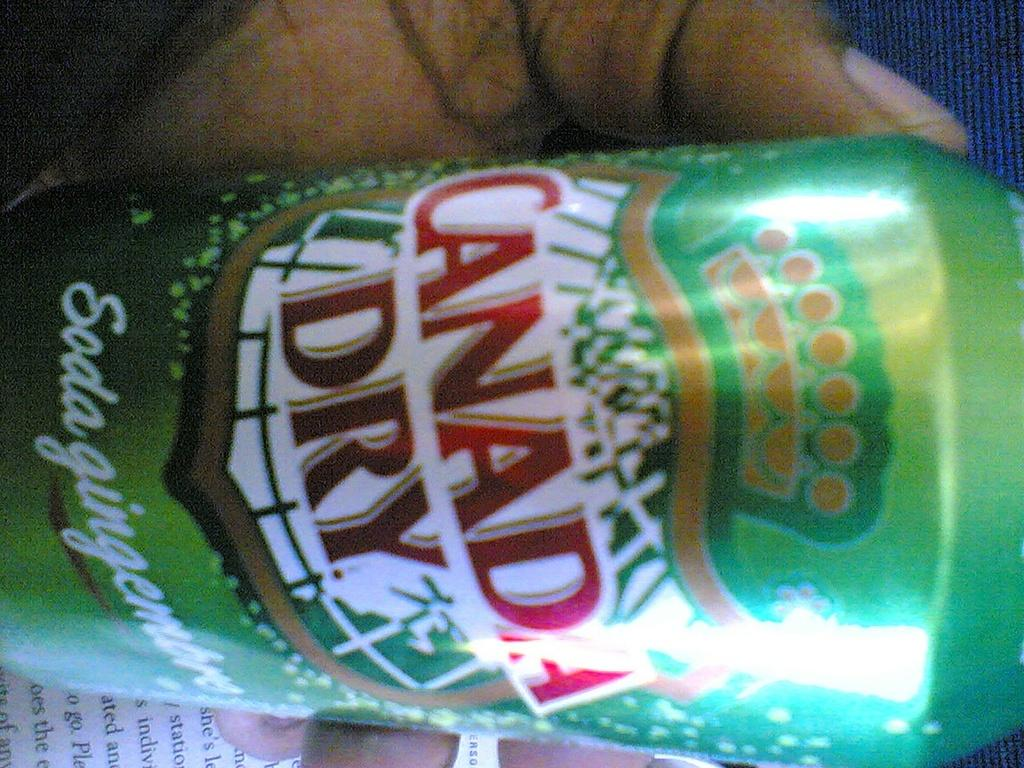<image>
Share a concise interpretation of the image provided. An extreme close up of a bottle of canada dry. 